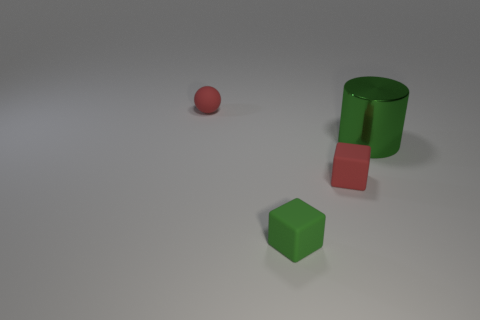Add 2 spheres. How many objects exist? 6 Subtract all cylinders. How many objects are left? 3 Subtract all large objects. Subtract all large blue objects. How many objects are left? 3 Add 4 tiny red objects. How many tiny red objects are left? 6 Add 2 large brown cubes. How many large brown cubes exist? 2 Subtract 0 blue blocks. How many objects are left? 4 